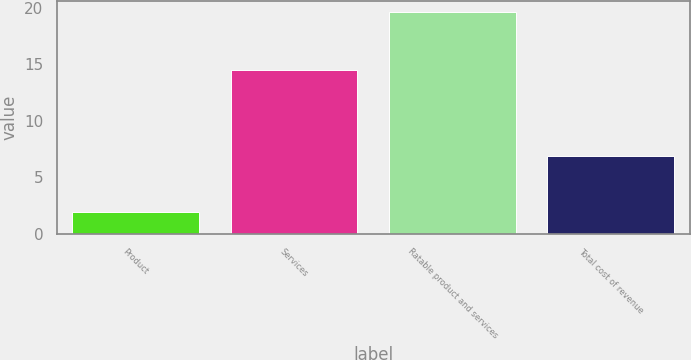Convert chart. <chart><loc_0><loc_0><loc_500><loc_500><bar_chart><fcel>Product<fcel>Services<fcel>Ratable product and services<fcel>Total cost of revenue<nl><fcel>1.9<fcel>14.5<fcel>19.6<fcel>6.9<nl></chart> 